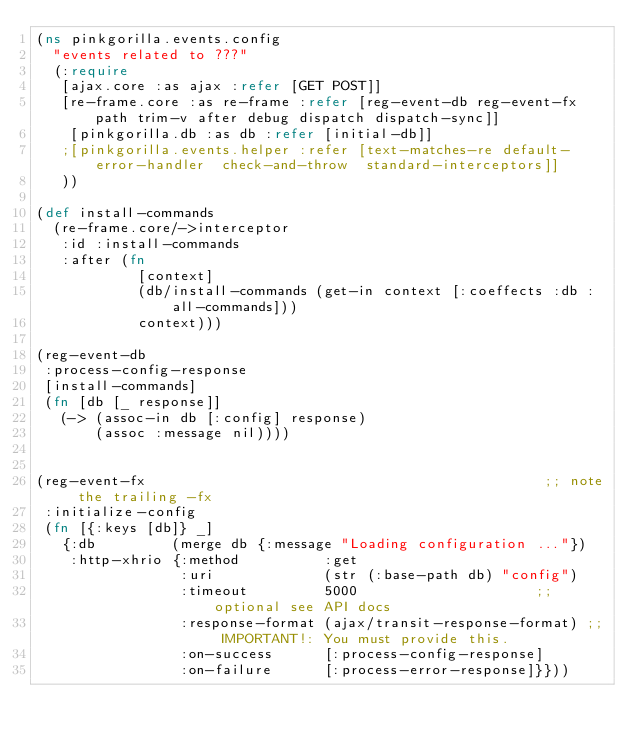<code> <loc_0><loc_0><loc_500><loc_500><_Clojure_>(ns pinkgorilla.events.config
  "events related to ???"
  (:require
   [ajax.core :as ajax :refer [GET POST]]
   [re-frame.core :as re-frame :refer [reg-event-db reg-event-fx path trim-v after debug dispatch dispatch-sync]]
    [pinkgorilla.db :as db :refer [initial-db]]
   ;[pinkgorilla.events.helper :refer [text-matches-re default-error-handler  check-and-throw  standard-interceptors]]
   ))

(def install-commands
  (re-frame.core/->interceptor
   :id :install-commands
   :after (fn
            [context]
            (db/install-commands (get-in context [:coeffects :db :all-commands]))
            context)))

(reg-event-db
 :process-config-response
 [install-commands]
 (fn [db [_ response]]
   (-> (assoc-in db [:config] response)
       (assoc :message nil))))


(reg-event-fx                                               ;; note the trailing -fx
 :initialize-config
 (fn [{:keys [db]} _]
   {:db         (merge db {:message "Loading configuration ..."})
    :http-xhrio {:method          :get
                 :uri             (str (:base-path db) "config")
                 :timeout         5000                     ;; optional see API docs
                 :response-format (ajax/transit-response-format) ;; IMPORTANT!: You must provide this.
                 :on-success      [:process-config-response]
                 :on-failure      [:process-error-response]}}))

</code> 